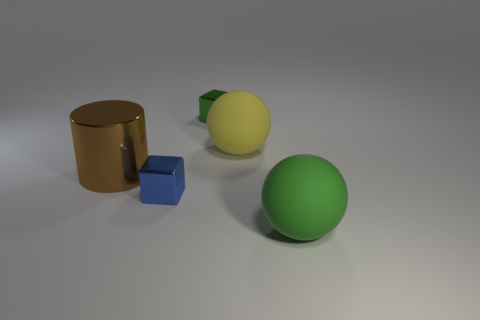Add 3 big yellow matte spheres. How many objects exist? 8 Subtract all cylinders. How many objects are left? 4 Add 1 big yellow things. How many big yellow things exist? 2 Subtract 1 yellow spheres. How many objects are left? 4 Subtract all small gray matte objects. Subtract all small green cubes. How many objects are left? 4 Add 5 large cylinders. How many large cylinders are left? 6 